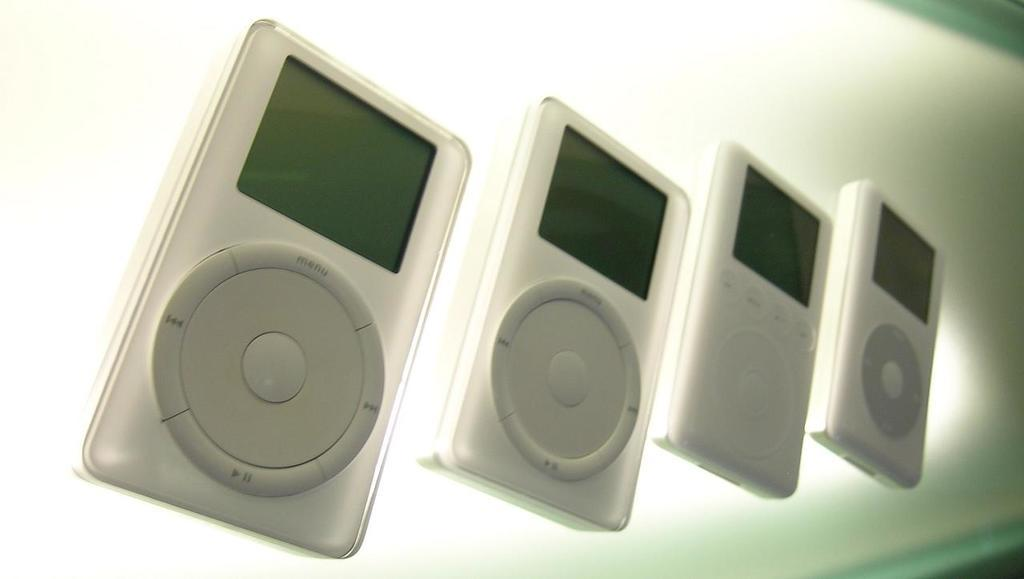How many iPods are visible in the image? There are four iPods in the image. How are the iPods arranged in the image? The iPods are kept one beside another. What type of journey is being discussed by the iPods in the image? The iPods are inanimate objects and cannot engage in discussions or journeys. 